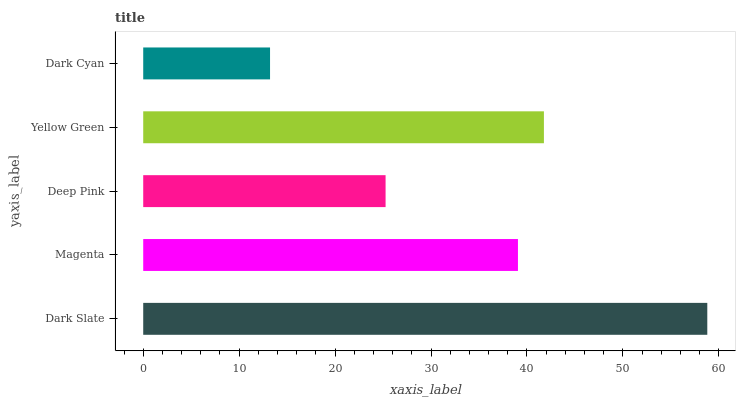Is Dark Cyan the minimum?
Answer yes or no. Yes. Is Dark Slate the maximum?
Answer yes or no. Yes. Is Magenta the minimum?
Answer yes or no. No. Is Magenta the maximum?
Answer yes or no. No. Is Dark Slate greater than Magenta?
Answer yes or no. Yes. Is Magenta less than Dark Slate?
Answer yes or no. Yes. Is Magenta greater than Dark Slate?
Answer yes or no. No. Is Dark Slate less than Magenta?
Answer yes or no. No. Is Magenta the high median?
Answer yes or no. Yes. Is Magenta the low median?
Answer yes or no. Yes. Is Yellow Green the high median?
Answer yes or no. No. Is Deep Pink the low median?
Answer yes or no. No. 